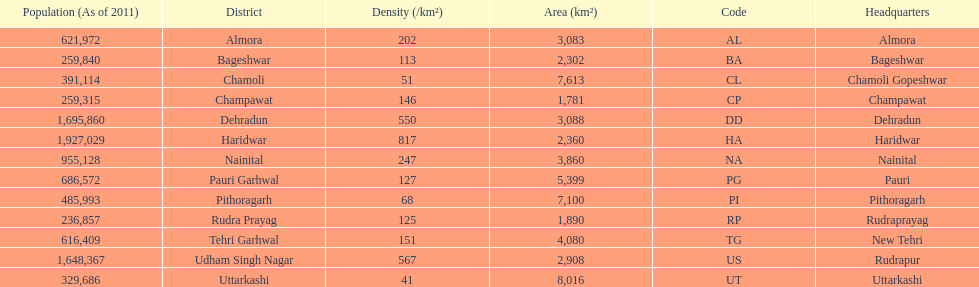Can you parse all the data within this table? {'header': ['Population (As of 2011)', 'District', 'Density (/km²)', 'Area (km²)', 'Code', 'Headquarters'], 'rows': [['621,972', 'Almora', '202', '3,083', 'AL', 'Almora'], ['259,840', 'Bageshwar', '113', '2,302', 'BA', 'Bageshwar'], ['391,114', 'Chamoli', '51', '7,613', 'CL', 'Chamoli Gopeshwar'], ['259,315', 'Champawat', '146', '1,781', 'CP', 'Champawat'], ['1,695,860', 'Dehradun', '550', '3,088', 'DD', 'Dehradun'], ['1,927,029', 'Haridwar', '817', '2,360', 'HA', 'Haridwar'], ['955,128', 'Nainital', '247', '3,860', 'NA', 'Nainital'], ['686,572', 'Pauri Garhwal', '127', '5,399', 'PG', 'Pauri'], ['485,993', 'Pithoragarh', '68', '7,100', 'PI', 'Pithoragarh'], ['236,857', 'Rudra Prayag', '125', '1,890', 'RP', 'Rudraprayag'], ['616,409', 'Tehri Garhwal', '151', '4,080', 'TG', 'New Tehri'], ['1,648,367', 'Udham Singh Nagar', '567', '2,908', 'US', 'Rudrapur'], ['329,686', 'Uttarkashi', '41', '8,016', 'UT', 'Uttarkashi']]} What is the next most populous district after haridwar? Dehradun. 